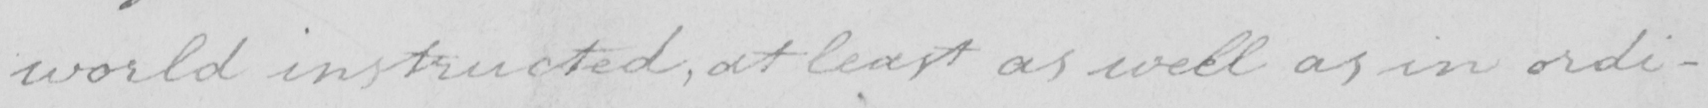Transcribe the text shown in this historical manuscript line. world instructed , at least as well as in ordi- 